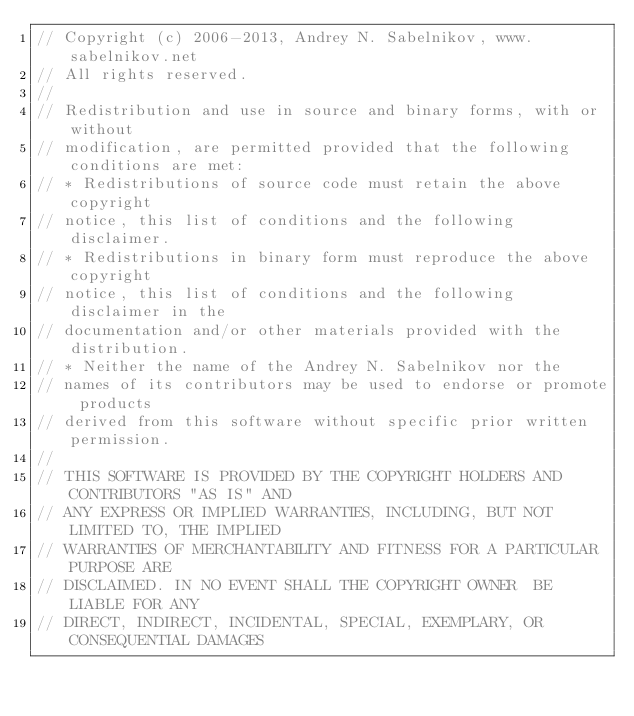Convert code to text. <code><loc_0><loc_0><loc_500><loc_500><_C_>// Copyright (c) 2006-2013, Andrey N. Sabelnikov, www.sabelnikov.net
// All rights reserved.
// 
// Redistribution and use in source and binary forms, with or without
// modification, are permitted provided that the following conditions are met:
// * Redistributions of source code must retain the above copyright
// notice, this list of conditions and the following disclaimer.
// * Redistributions in binary form must reproduce the above copyright
// notice, this list of conditions and the following disclaimer in the
// documentation and/or other materials provided with the distribution.
// * Neither the name of the Andrey N. Sabelnikov nor the
// names of its contributors may be used to endorse or promote products
// derived from this software without specific prior written permission.
// 
// THIS SOFTWARE IS PROVIDED BY THE COPYRIGHT HOLDERS AND CONTRIBUTORS "AS IS" AND
// ANY EXPRESS OR IMPLIED WARRANTIES, INCLUDING, BUT NOT LIMITED TO, THE IMPLIED
// WARRANTIES OF MERCHANTABILITY AND FITNESS FOR A PARTICULAR PURPOSE ARE
// DISCLAIMED. IN NO EVENT SHALL THE COPYRIGHT OWNER  BE LIABLE FOR ANY
// DIRECT, INDIRECT, INCIDENTAL, SPECIAL, EXEMPLARY, OR CONSEQUENTIAL DAMAGES</code> 